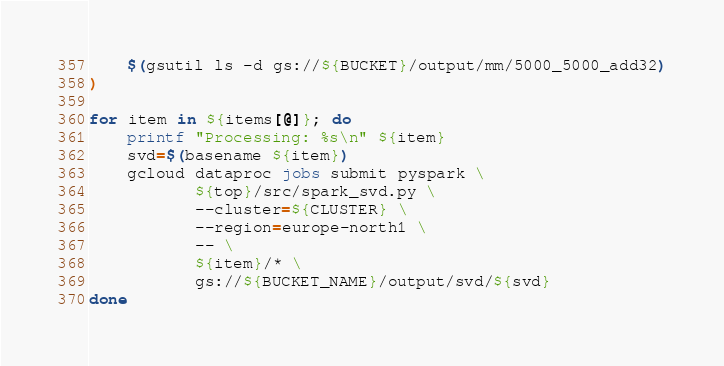Convert code to text. <code><loc_0><loc_0><loc_500><loc_500><_Bash_>    $(gsutil ls -d gs://${BUCKET}/output/mm/5000_5000_add32)
)

for item in ${items[@]}; do
    printf "Processing: %s\n" ${item}
    svd=$(basename ${item})
    gcloud dataproc jobs submit pyspark \
           ${top}/src/spark_svd.py \
           --cluster=${CLUSTER} \
           --region=europe-north1 \
           -- \
           ${item}/* \
           gs://${BUCKET_NAME}/output/svd/${svd}
done
</code> 